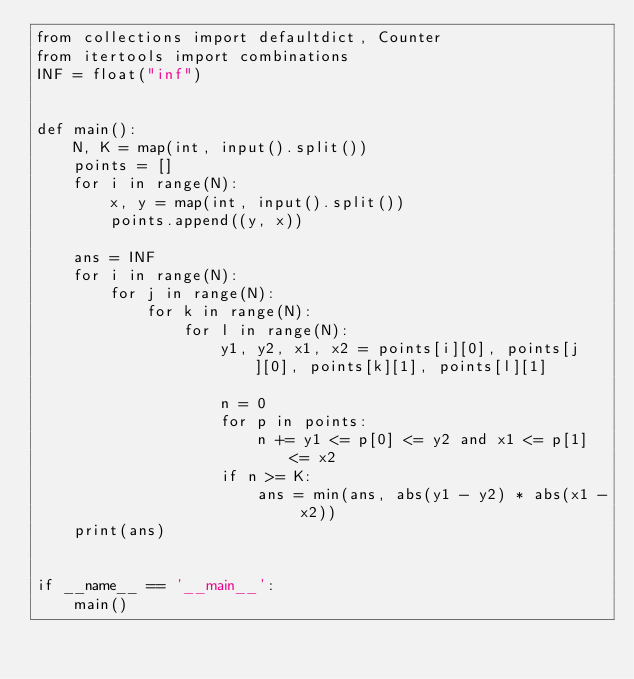<code> <loc_0><loc_0><loc_500><loc_500><_Python_>from collections import defaultdict, Counter
from itertools import combinations
INF = float("inf")


def main():
    N, K = map(int, input().split())
    points = []
    for i in range(N):
        x, y = map(int, input().split())
        points.append((y, x))

    ans = INF
    for i in range(N):
        for j in range(N):
            for k in range(N):
                for l in range(N):
                    y1, y2, x1, x2 = points[i][0], points[j][0], points[k][1], points[l][1]

                    n = 0
                    for p in points:
                        n += y1 <= p[0] <= y2 and x1 <= p[1] <= x2
                    if n >= K:
                        ans = min(ans, abs(y1 - y2) * abs(x1 - x2))
    print(ans)


if __name__ == '__main__':
    main()
</code> 